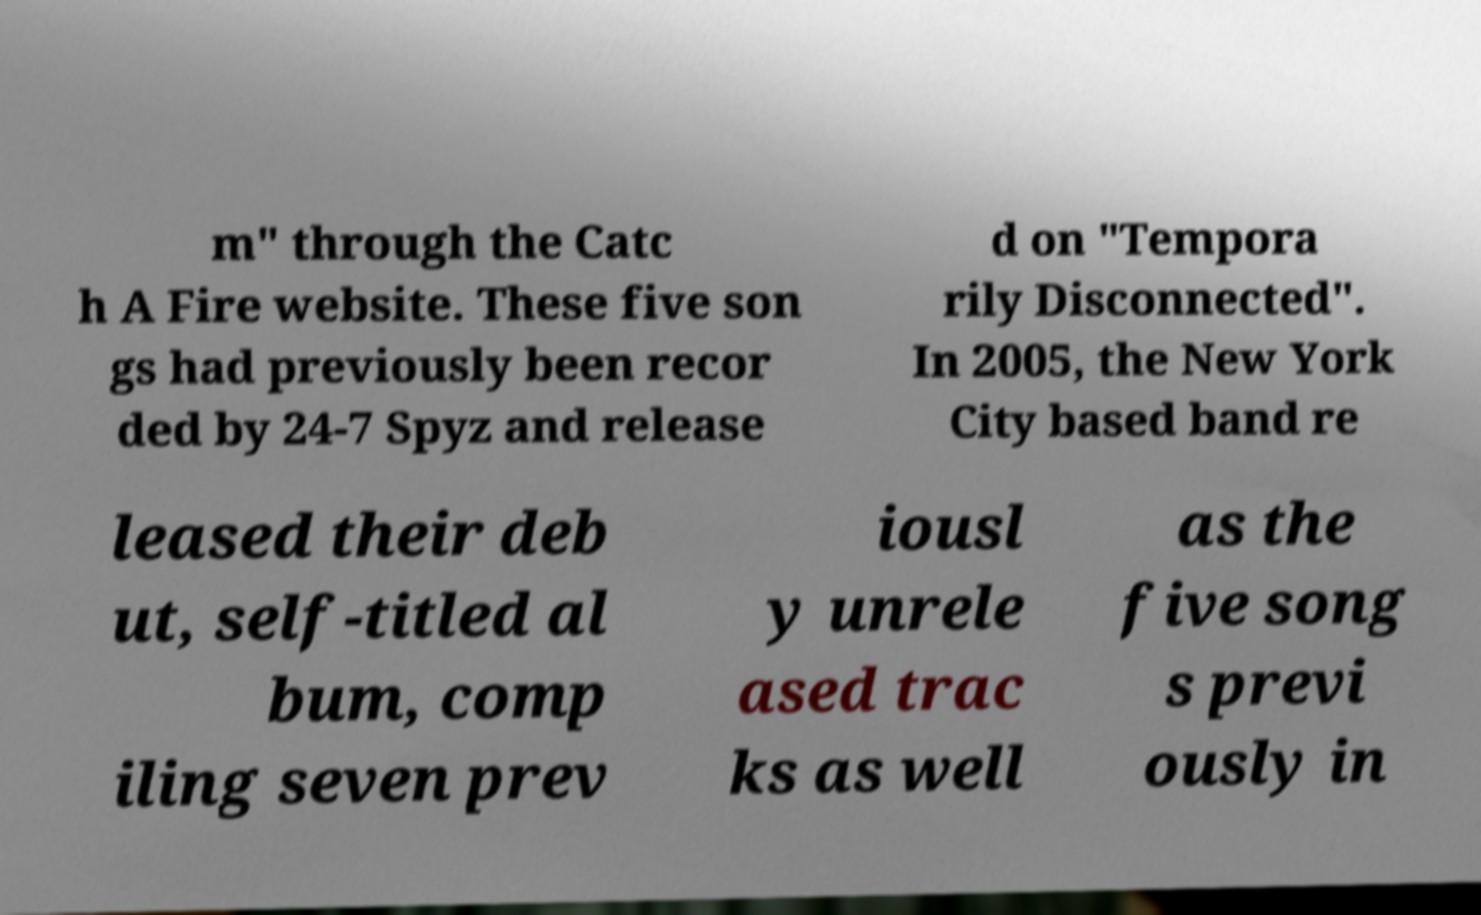Can you read and provide the text displayed in the image?This photo seems to have some interesting text. Can you extract and type it out for me? m" through the Catc h A Fire website. These five son gs had previously been recor ded by 24-7 Spyz and release d on "Tempora rily Disconnected". In 2005, the New York City based band re leased their deb ut, self-titled al bum, comp iling seven prev iousl y unrele ased trac ks as well as the five song s previ ously in 